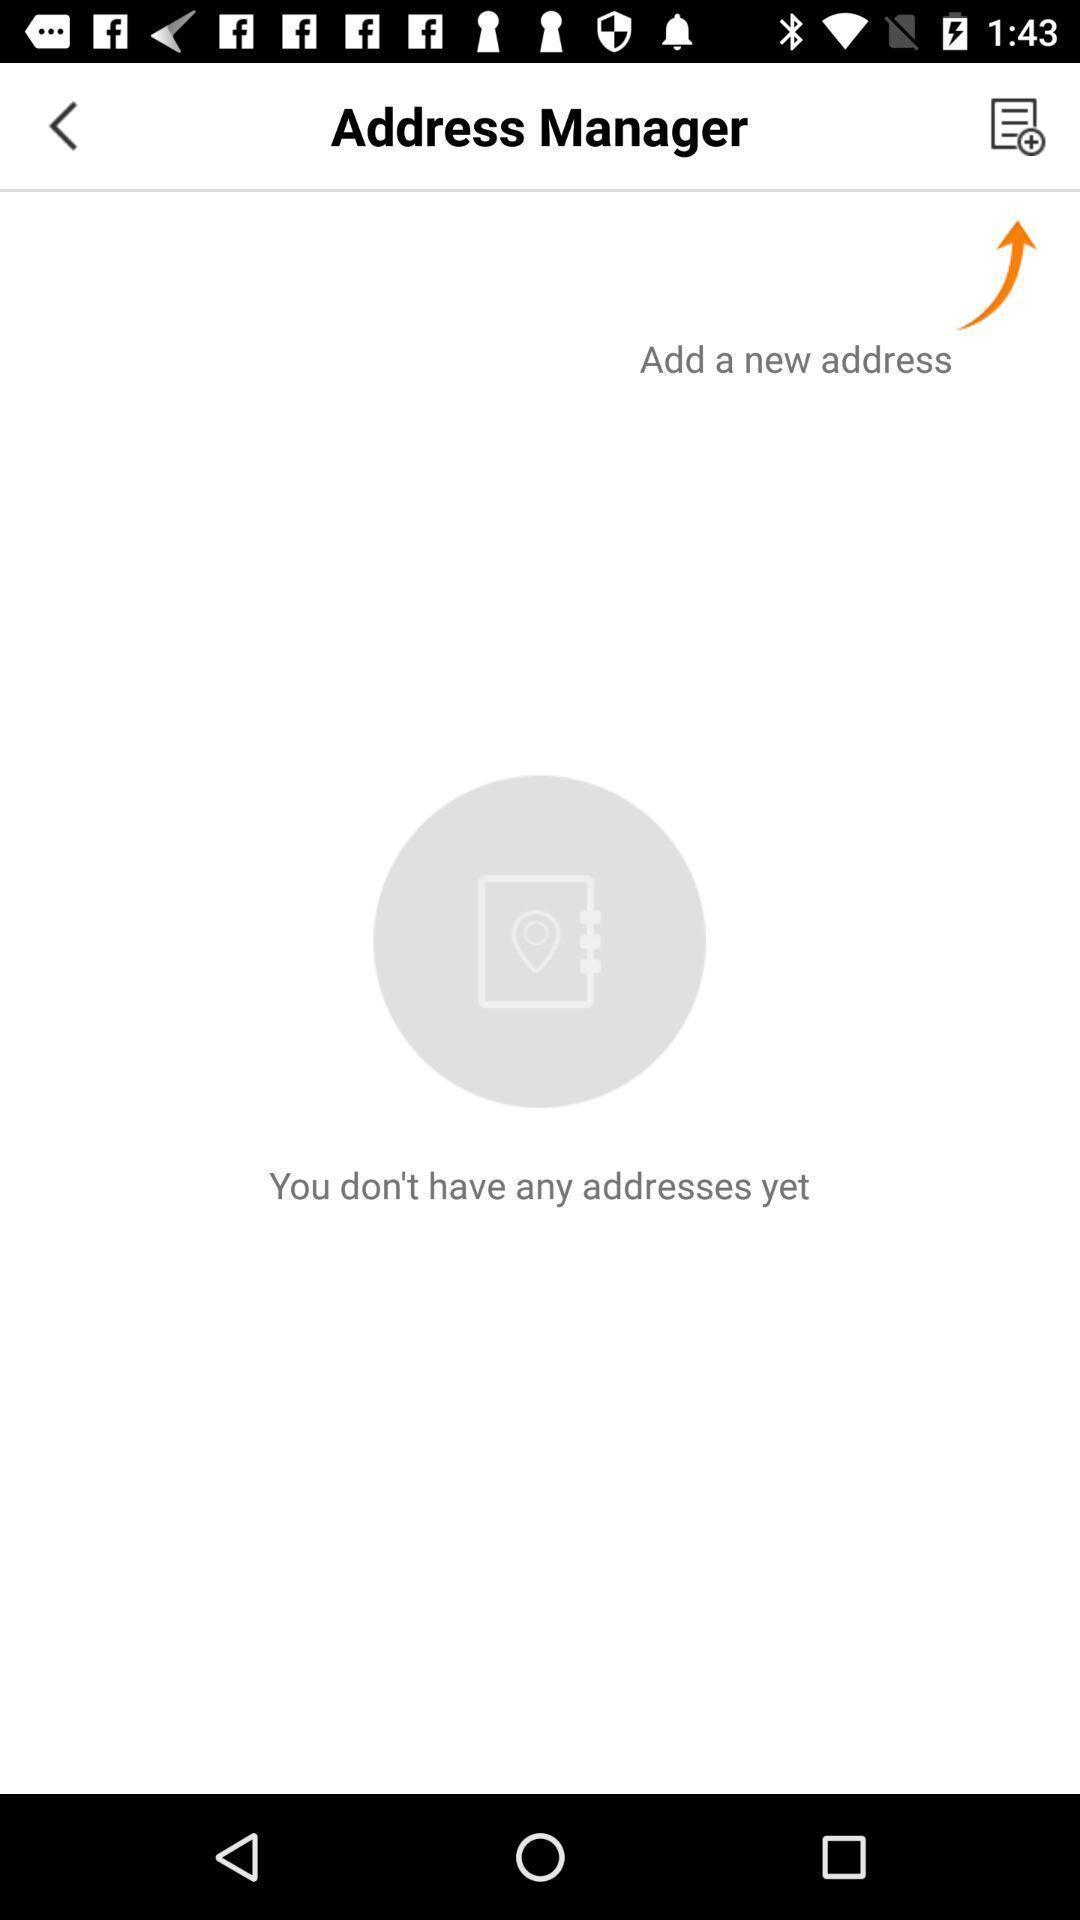What details can you identify in this image? Page to add address in the address manager. 